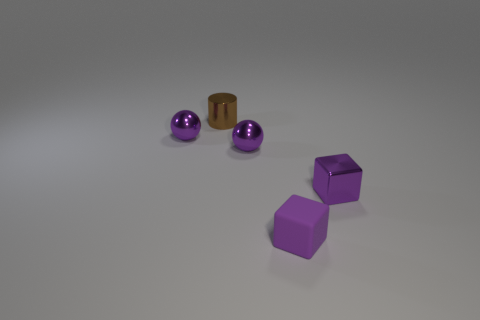Subtract all balls. How many objects are left? 3 Add 2 purple metal objects. How many objects exist? 7 Subtract all cyan cylinders. Subtract all green cubes. How many cylinders are left? 1 Subtract all brown cylinders. How many red balls are left? 0 Subtract all tiny rubber cylinders. Subtract all small metal cylinders. How many objects are left? 4 Add 5 brown objects. How many brown objects are left? 6 Add 4 green matte cylinders. How many green matte cylinders exist? 4 Subtract 0 cyan cylinders. How many objects are left? 5 Subtract 2 cubes. How many cubes are left? 0 